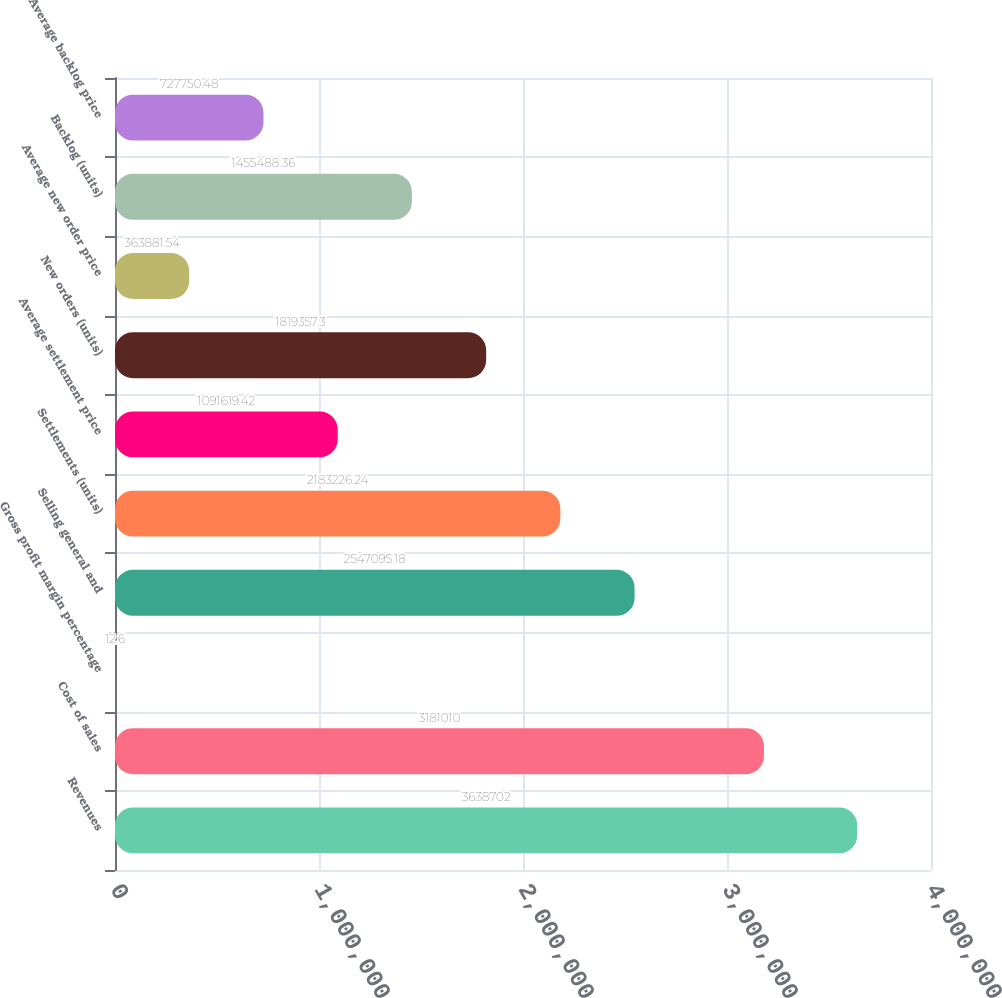<chart> <loc_0><loc_0><loc_500><loc_500><bar_chart><fcel>Revenues<fcel>Cost of sales<fcel>Gross profit margin percentage<fcel>Selling general and<fcel>Settlements (units)<fcel>Average settlement price<fcel>New orders (units)<fcel>Average new order price<fcel>Backlog (units)<fcel>Average backlog price<nl><fcel>3.6387e+06<fcel>3.18101e+06<fcel>12.6<fcel>2.5471e+06<fcel>2.18323e+06<fcel>1.09162e+06<fcel>1.81936e+06<fcel>363882<fcel>1.45549e+06<fcel>727750<nl></chart> 